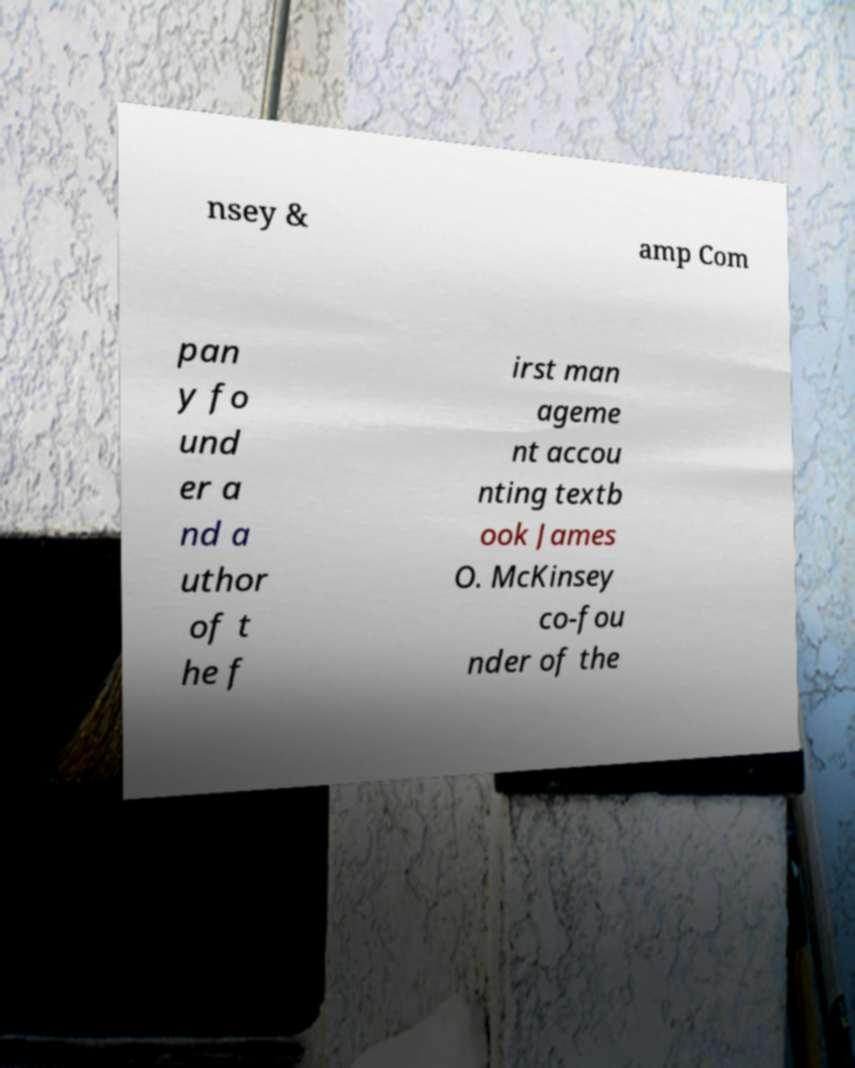For documentation purposes, I need the text within this image transcribed. Could you provide that? nsey & amp Com pan y fo und er a nd a uthor of t he f irst man ageme nt accou nting textb ook James O. McKinsey co-fou nder of the 